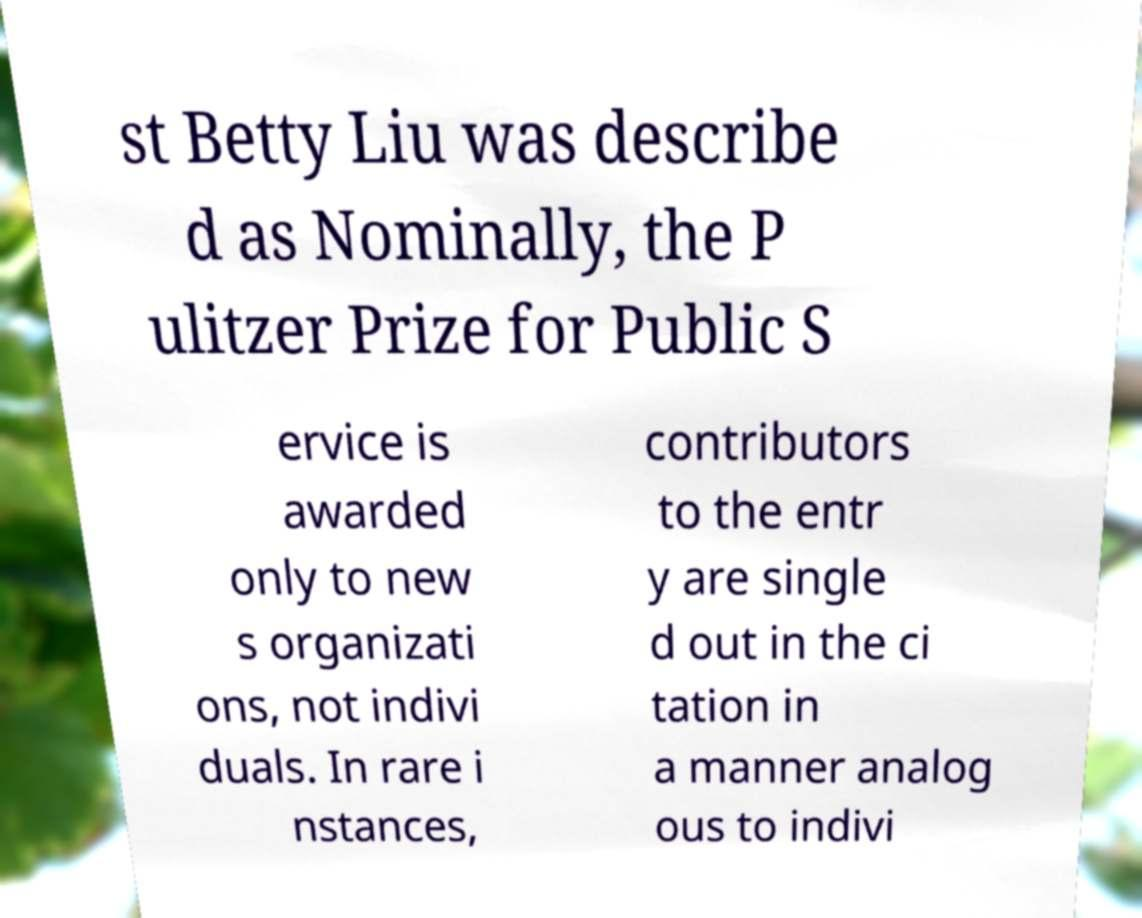Please identify and transcribe the text found in this image. st Betty Liu was describe d as Nominally, the P ulitzer Prize for Public S ervice is awarded only to new s organizati ons, not indivi duals. In rare i nstances, contributors to the entr y are single d out in the ci tation in a manner analog ous to indivi 